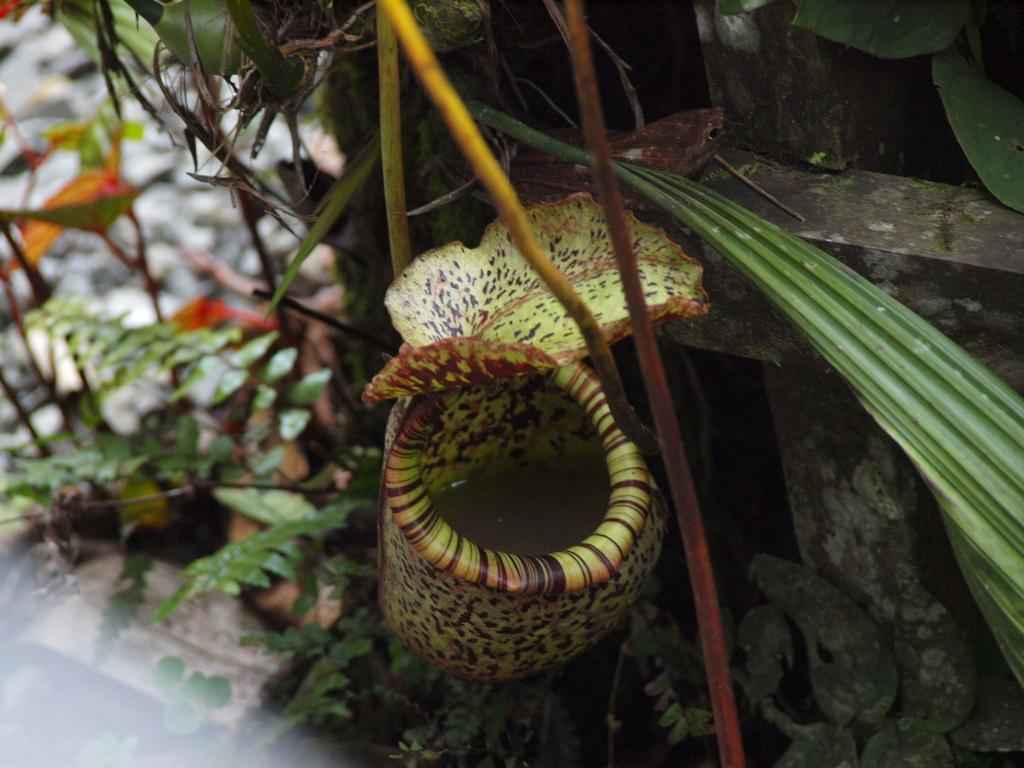What type of living organisms can be seen in the image? Plants can be seen in the image. What part of the plants is visible in the image? Leaves are present in the image. What material is visible in the image? Wood is visible in the image. What surface is at the bottom of the image? There is a floor at the bottom of the image. What type of glass object is visible in the image? There is no glass object present in the image. How does the rake contribute to the overall appearance of the image? There is no rake present in the image, so it cannot contribute to the overall appearance. 